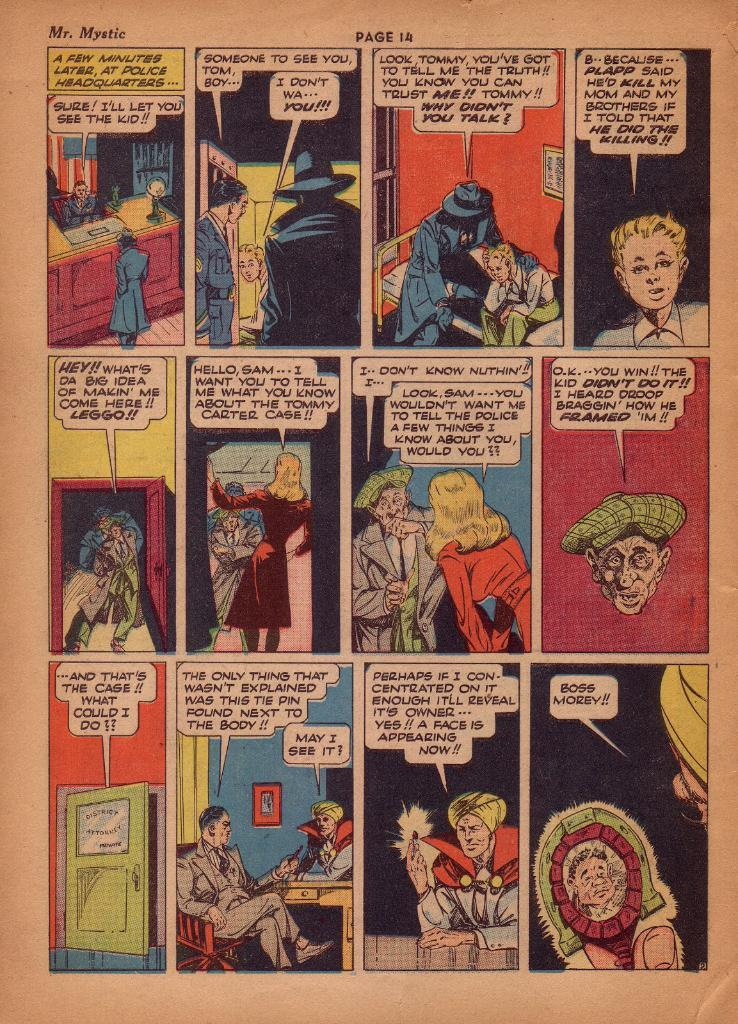<image>
Offer a succinct explanation of the picture presented. A Mr. Mystic cartoon consists of twelve colorful panels. 